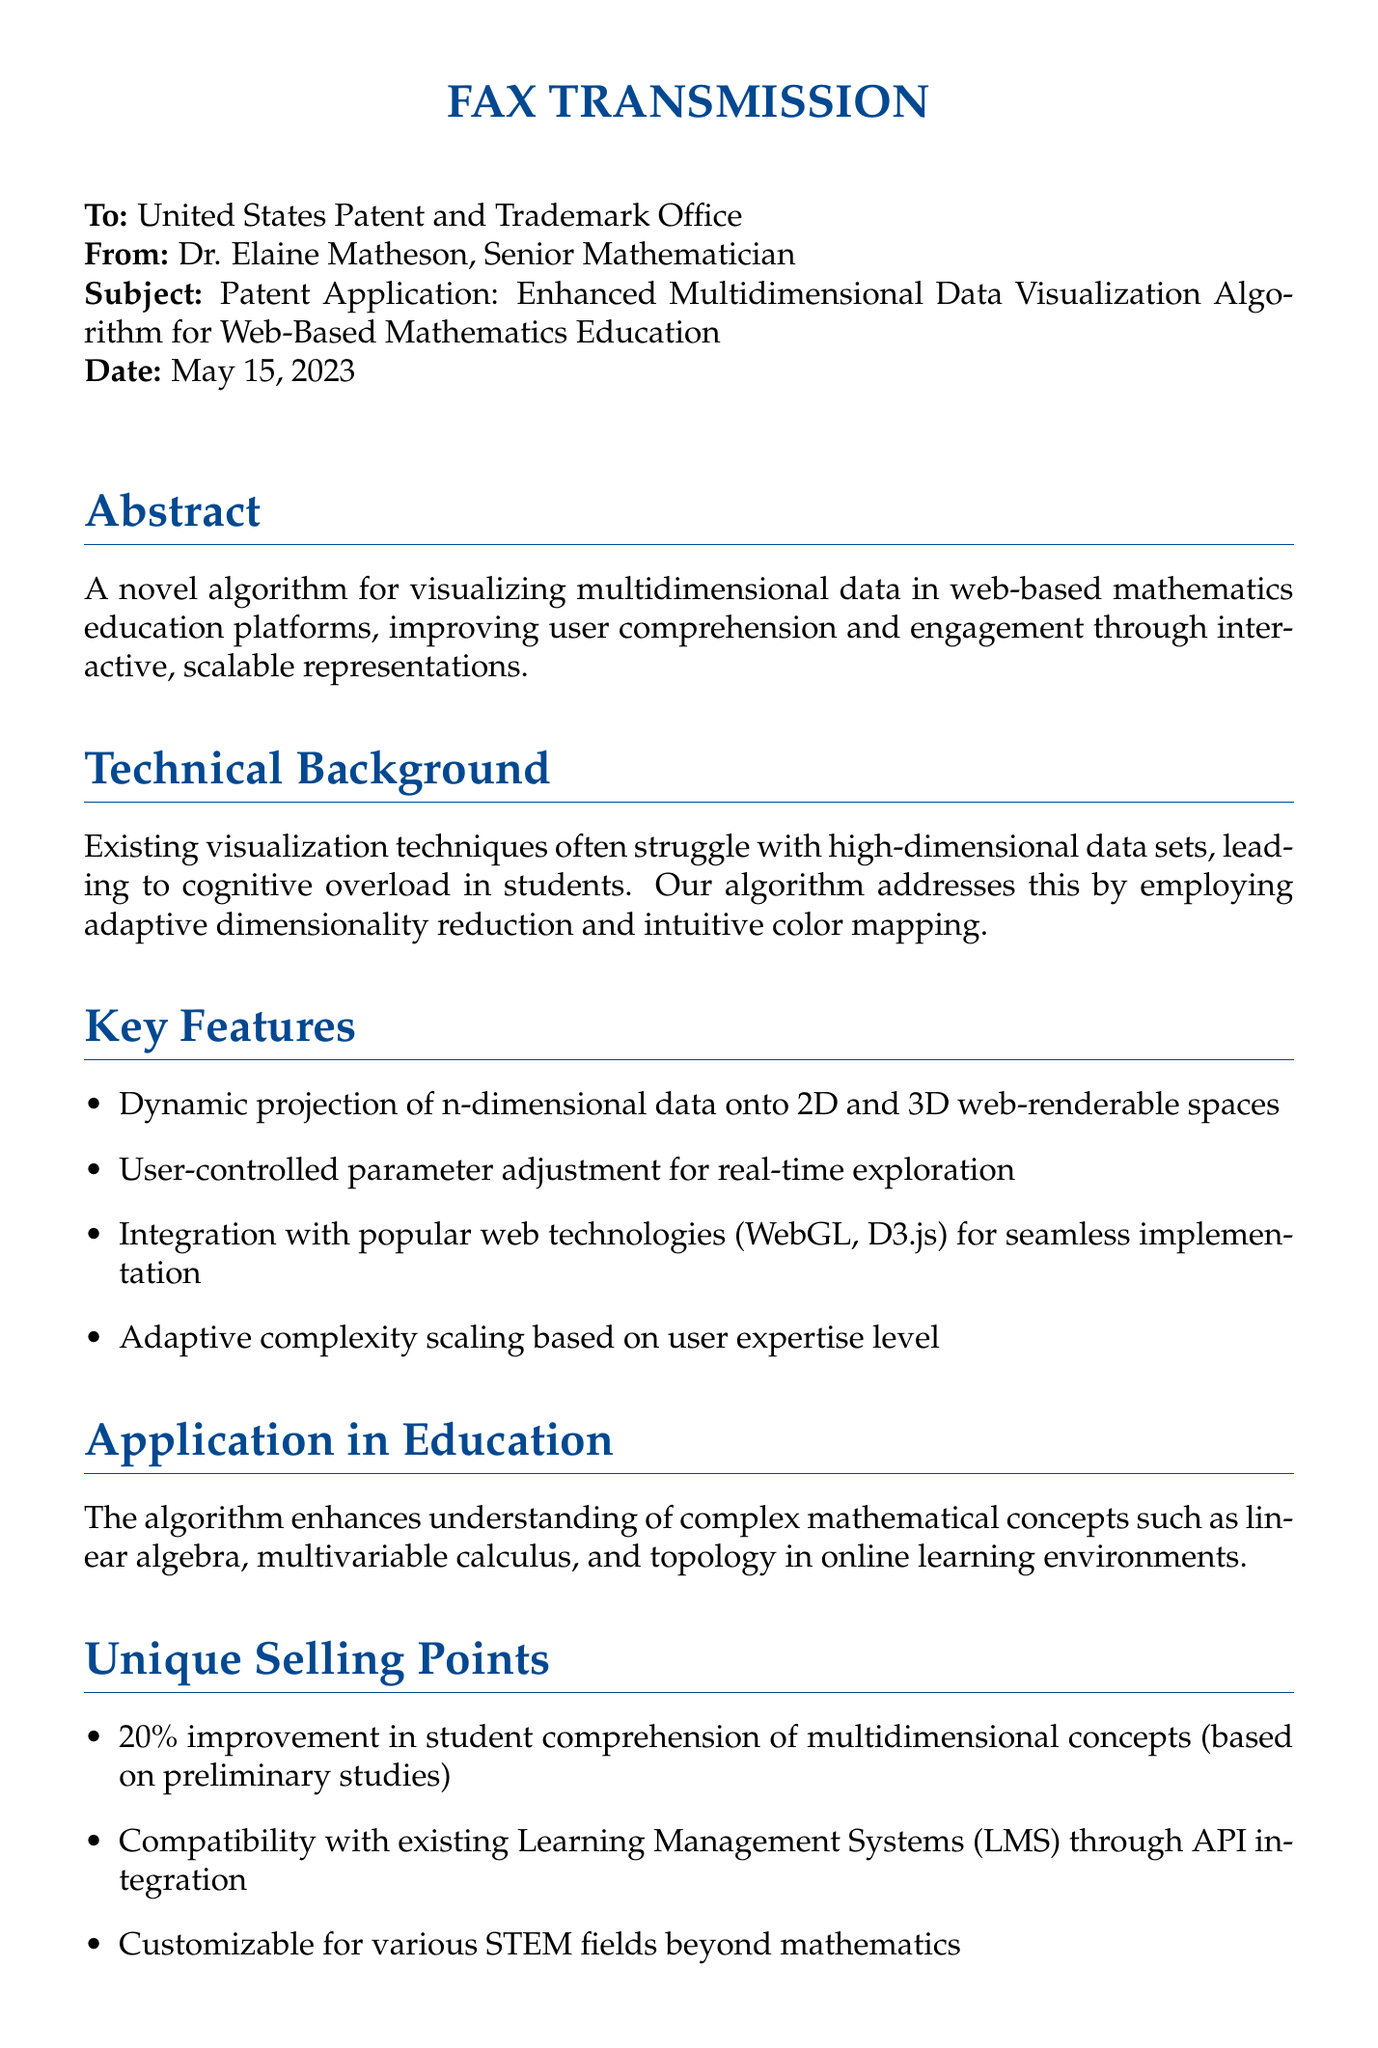What is the date of the fax? The date of the fax is explicitly mentioned in the document under the "Date" field.
Answer: May 15, 2023 Who is the sender of the fax? The sender of the fax is identified at the beginning as Dr. Elaine Matheson.
Answer: Dr. Elaine Matheson What main problem does the algorithm address? The problem is specified in the Technical Background section regarding existing visualization techniques.
Answer: Cognitive overload What is the expected improvement in student comprehension? The expected improvement is stated in the Unique Selling Points section, based on preliminary studies.
Answer: 20% What technologies does the algorithm integrate with? The technologies are mentioned in the Key Features section, highlighting compatibility with specific tools.
Answer: WebGL, D3.js What mathematical concepts does the algorithm enhance understanding of? The application in education specifies the concepts that benefit from the algorithm.
Answer: Linear algebra, multivariable calculus, topology What is the projected value of the global e-learning market by 2025? This information is provided in the Market Potential section as a statistic.
Answer: $325 billion What type of document is this? The nature of the document can be identified from the title at the beginning.
Answer: Fax Transmission 